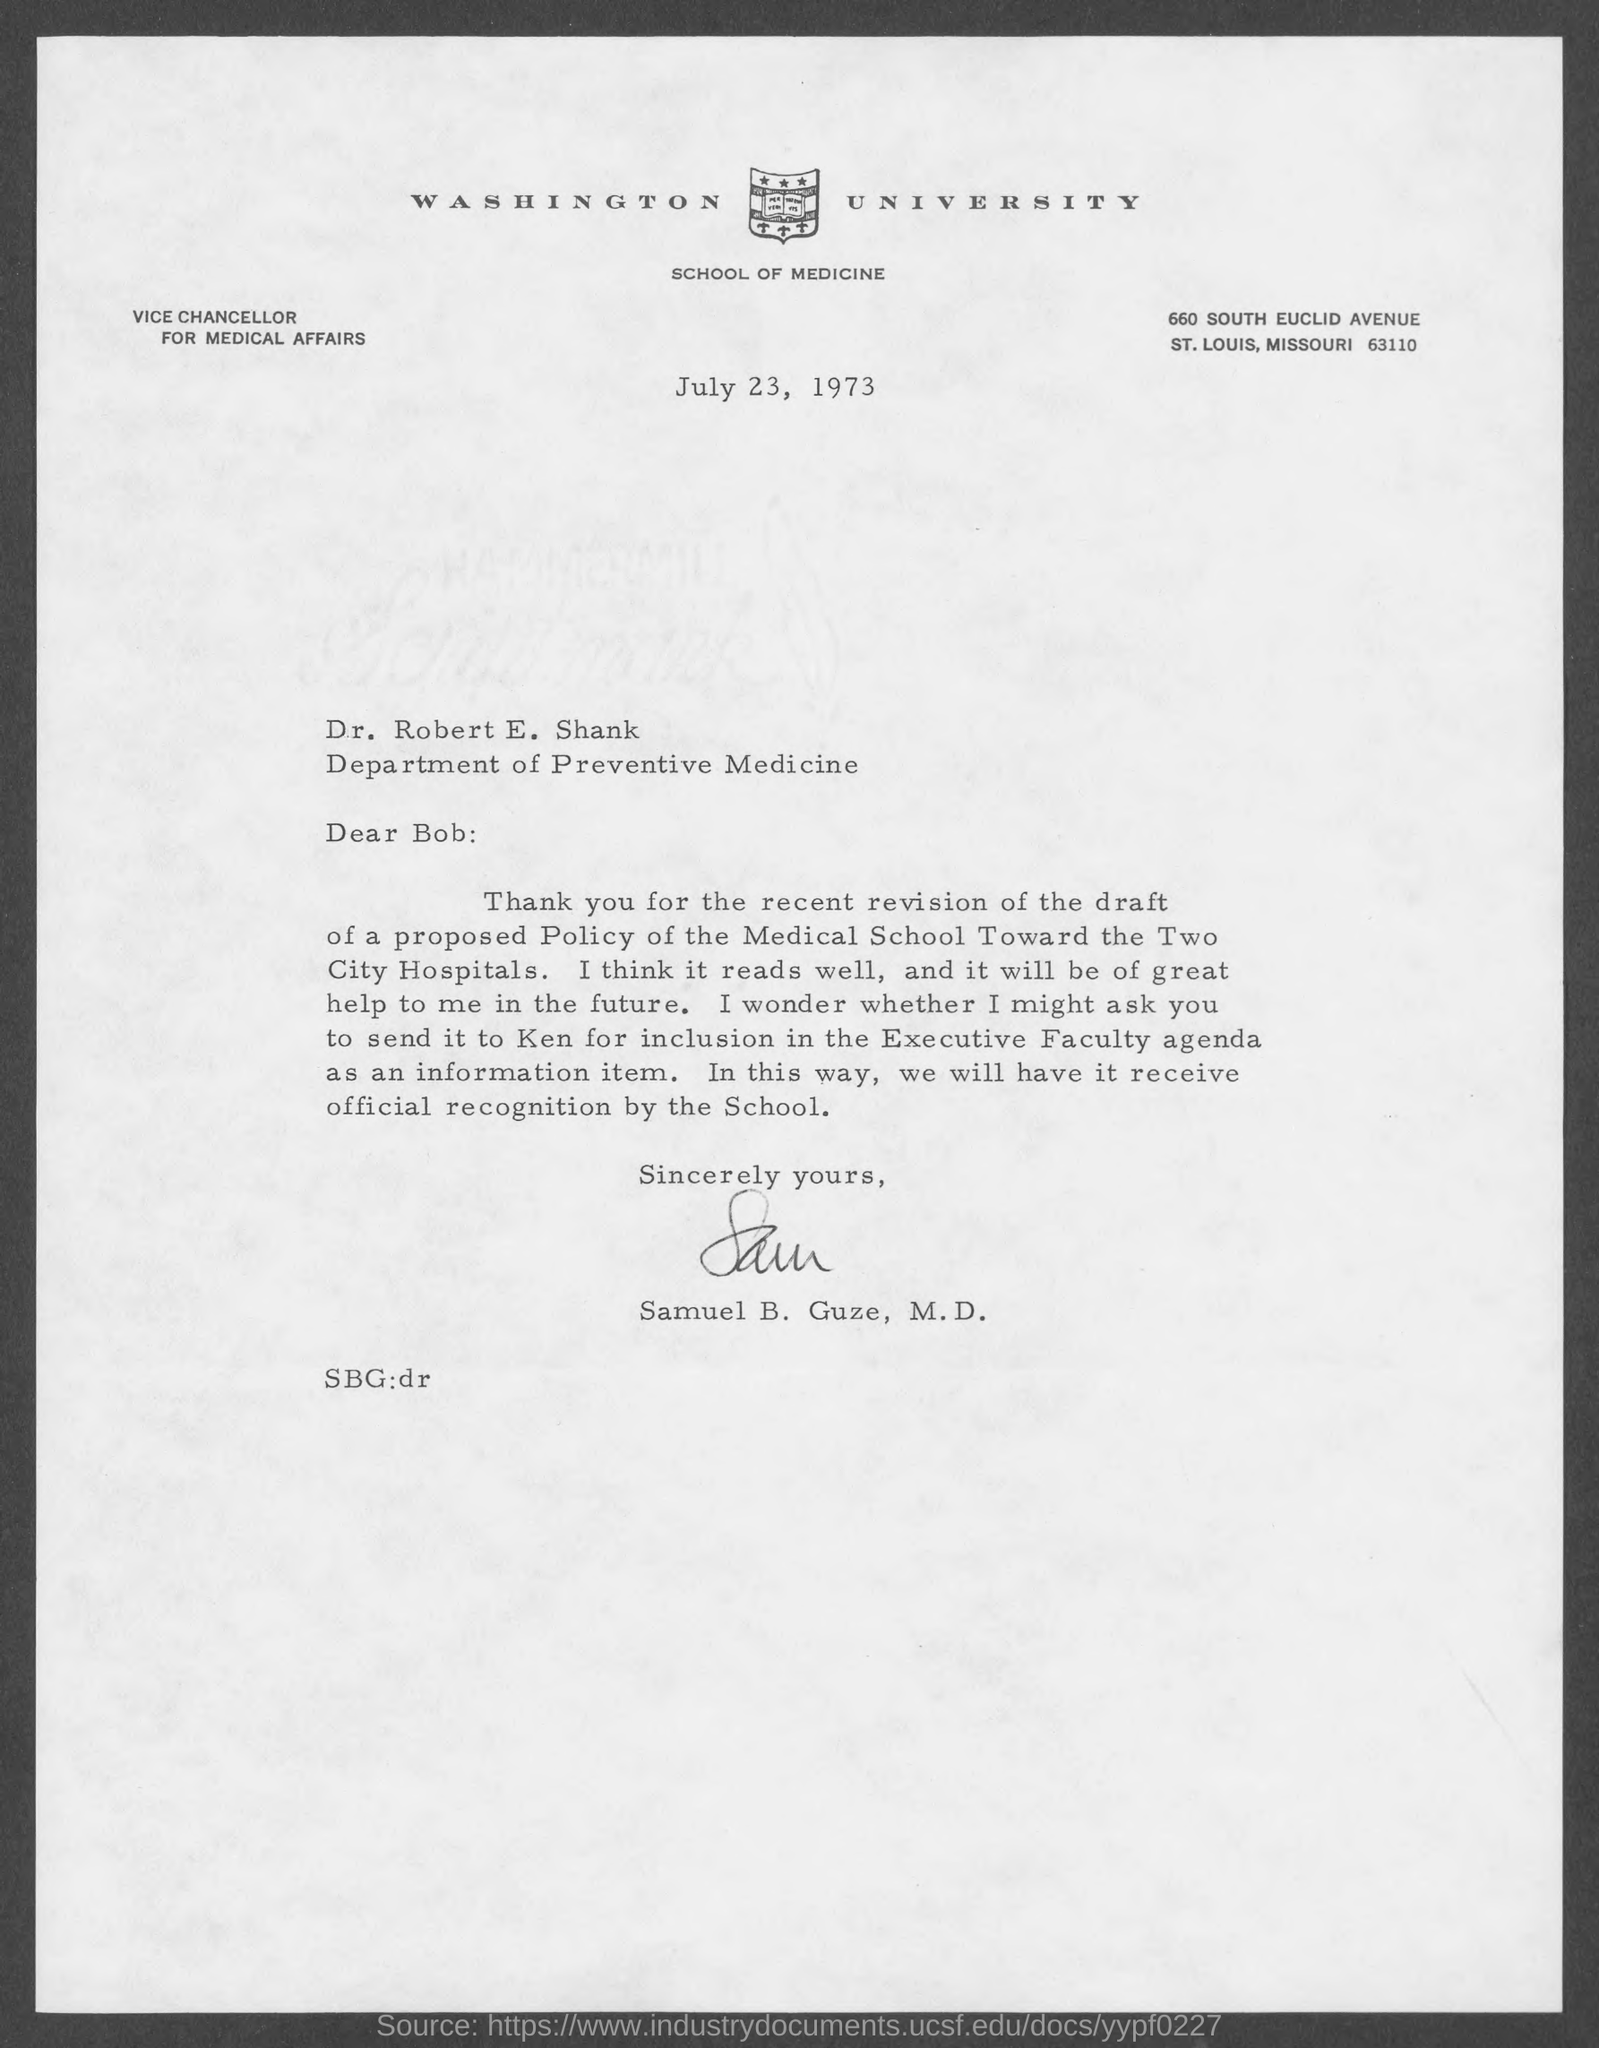Specify some key components in this picture. The letter is addressed to Dr. Robert E. Shank. The letter is from Samuel B. Guze. The speaker is asking who the person they are speaking to is asking to send the message to. The person they are referring to is named Ken. The date on the document is July 23, 1973. 